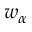<formula> <loc_0><loc_0><loc_500><loc_500>w _ { \alpha }</formula> 